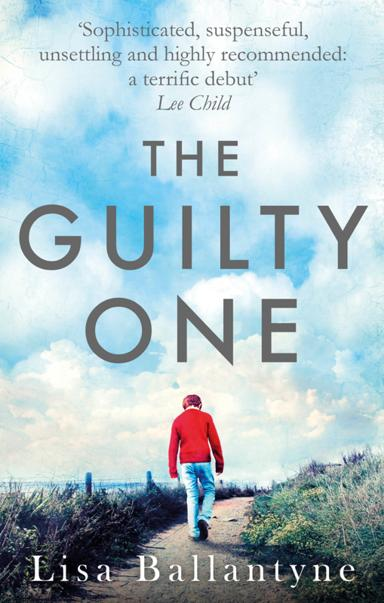Who has given a recommendation for the book? The acclaimed author Lee Child has endorsed 'The Guilty One,' describing it as 'Sophisticated, suspenseful, unsettling, and highly recommended.' His seal of approval, especially noting that it's a 'terrific debut,' signals this novel as a must-read for fans of thought-provoking and well-crafted legal dramas. 